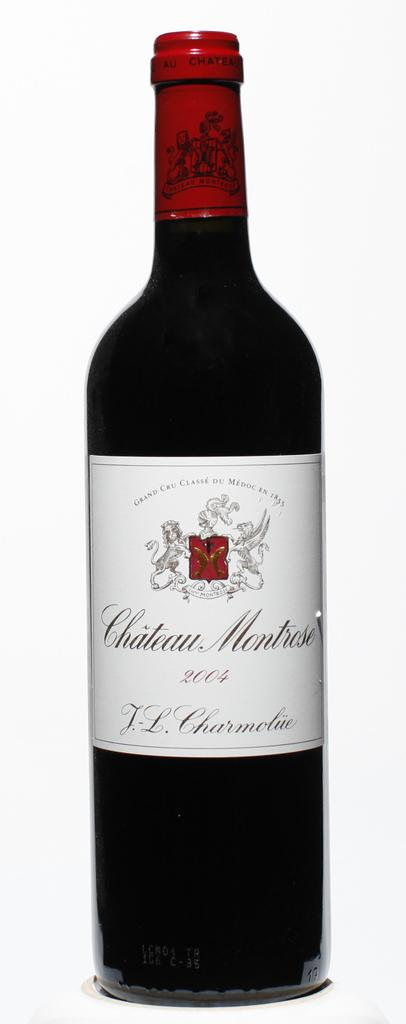<image>
Share a concise interpretation of the image provided. An unopened bottle of Chateau Montrose has an image of a lion, and a Pegasus on each side of their crest, at the top of the label. 